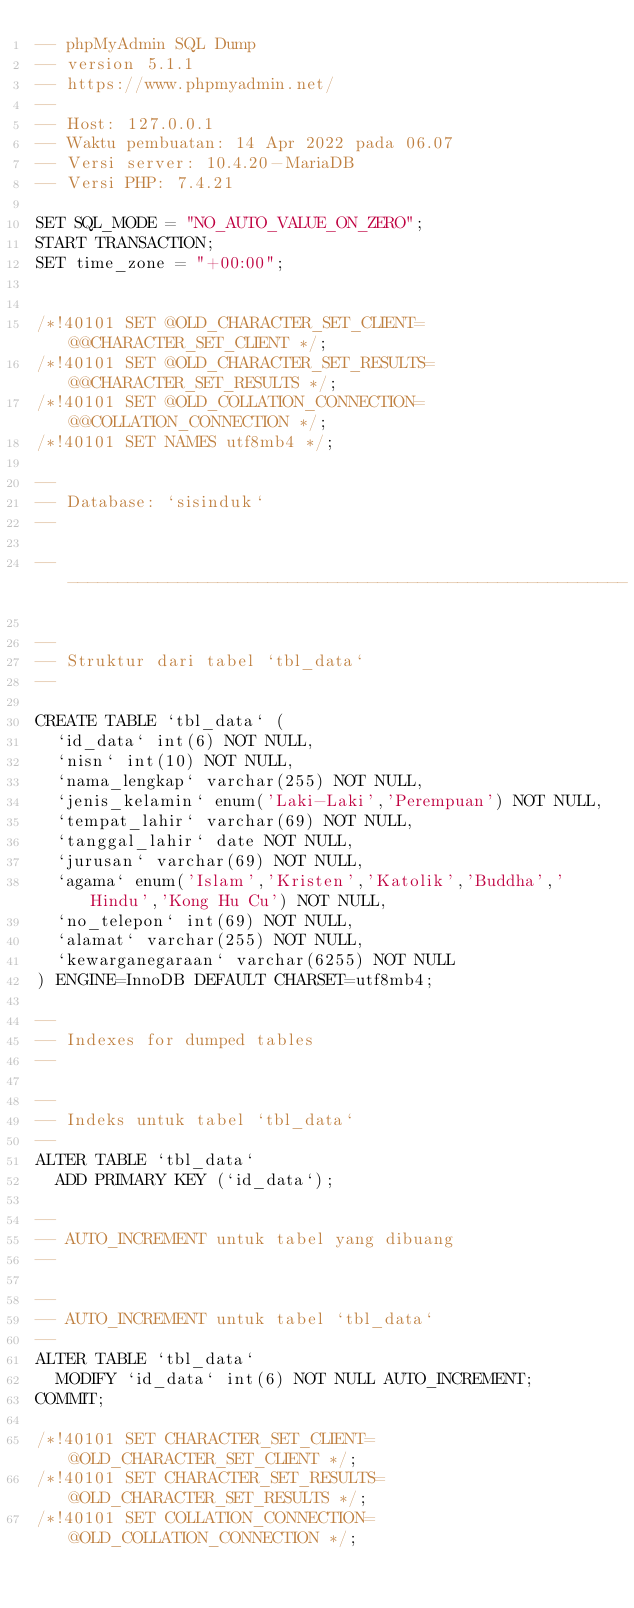Convert code to text. <code><loc_0><loc_0><loc_500><loc_500><_SQL_>-- phpMyAdmin SQL Dump
-- version 5.1.1
-- https://www.phpmyadmin.net/
--
-- Host: 127.0.0.1
-- Waktu pembuatan: 14 Apr 2022 pada 06.07
-- Versi server: 10.4.20-MariaDB
-- Versi PHP: 7.4.21

SET SQL_MODE = "NO_AUTO_VALUE_ON_ZERO";
START TRANSACTION;
SET time_zone = "+00:00";


/*!40101 SET @OLD_CHARACTER_SET_CLIENT=@@CHARACTER_SET_CLIENT */;
/*!40101 SET @OLD_CHARACTER_SET_RESULTS=@@CHARACTER_SET_RESULTS */;
/*!40101 SET @OLD_COLLATION_CONNECTION=@@COLLATION_CONNECTION */;
/*!40101 SET NAMES utf8mb4 */;

--
-- Database: `sisinduk`
--

-- --------------------------------------------------------

--
-- Struktur dari tabel `tbl_data`
--

CREATE TABLE `tbl_data` (
  `id_data` int(6) NOT NULL,
  `nisn` int(10) NOT NULL,
  `nama_lengkap` varchar(255) NOT NULL,
  `jenis_kelamin` enum('Laki-Laki','Perempuan') NOT NULL,
  `tempat_lahir` varchar(69) NOT NULL,
  `tanggal_lahir` date NOT NULL,
  `jurusan` varchar(69) NOT NULL,
  `agama` enum('Islam','Kristen','Katolik','Buddha','Hindu','Kong Hu Cu') NOT NULL,
  `no_telepon` int(69) NOT NULL,
  `alamat` varchar(255) NOT NULL,
  `kewarganegaraan` varchar(6255) NOT NULL
) ENGINE=InnoDB DEFAULT CHARSET=utf8mb4;

--
-- Indexes for dumped tables
--

--
-- Indeks untuk tabel `tbl_data`
--
ALTER TABLE `tbl_data`
  ADD PRIMARY KEY (`id_data`);

--
-- AUTO_INCREMENT untuk tabel yang dibuang
--

--
-- AUTO_INCREMENT untuk tabel `tbl_data`
--
ALTER TABLE `tbl_data`
  MODIFY `id_data` int(6) NOT NULL AUTO_INCREMENT;
COMMIT;

/*!40101 SET CHARACTER_SET_CLIENT=@OLD_CHARACTER_SET_CLIENT */;
/*!40101 SET CHARACTER_SET_RESULTS=@OLD_CHARACTER_SET_RESULTS */;
/*!40101 SET COLLATION_CONNECTION=@OLD_COLLATION_CONNECTION */;
</code> 